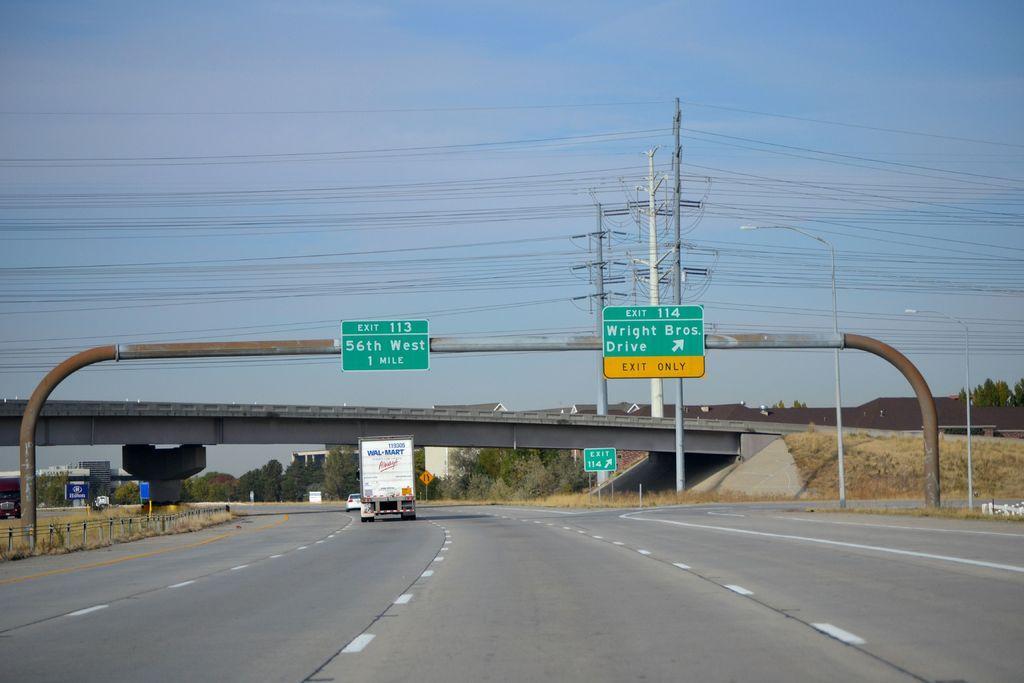In one or two sentences, can you explain what this image depicts? In this picture I can see couple of cars and a truck moving on the road and I can see couple of boards with some text and I can see a bridge and few houses and buildings and I can see few poles and a blue sky. 